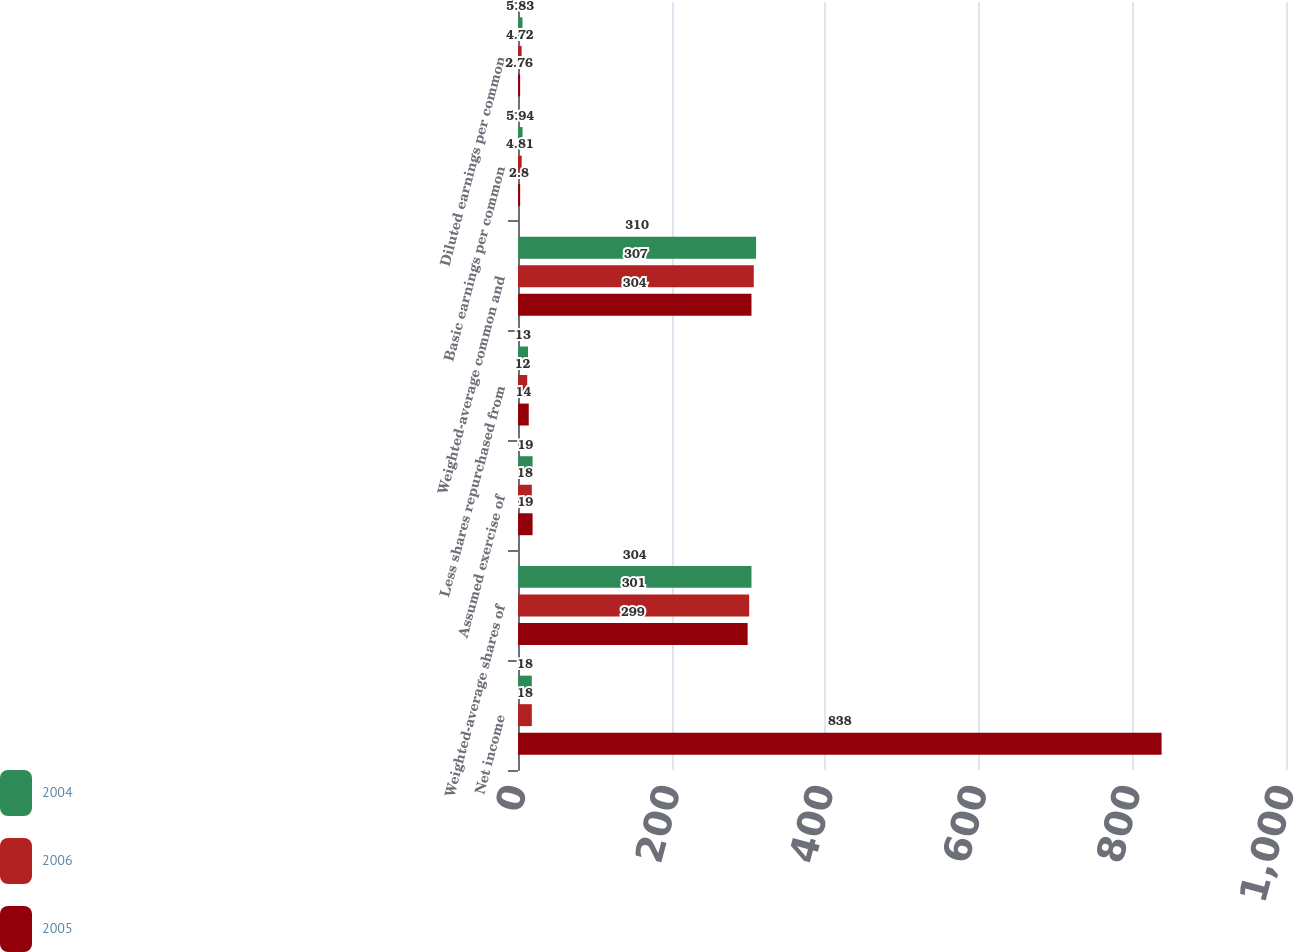<chart> <loc_0><loc_0><loc_500><loc_500><stacked_bar_chart><ecel><fcel>Net income<fcel>Weighted-average shares of<fcel>Assumed exercise of<fcel>Less shares repurchased from<fcel>Weighted-average common and<fcel>Basic earnings per common<fcel>Diluted earnings per common<nl><fcel>2004<fcel>18<fcel>304<fcel>19<fcel>13<fcel>310<fcel>5.94<fcel>5.83<nl><fcel>2006<fcel>18<fcel>301<fcel>18<fcel>12<fcel>307<fcel>4.81<fcel>4.72<nl><fcel>2005<fcel>838<fcel>299<fcel>19<fcel>14<fcel>304<fcel>2.8<fcel>2.76<nl></chart> 